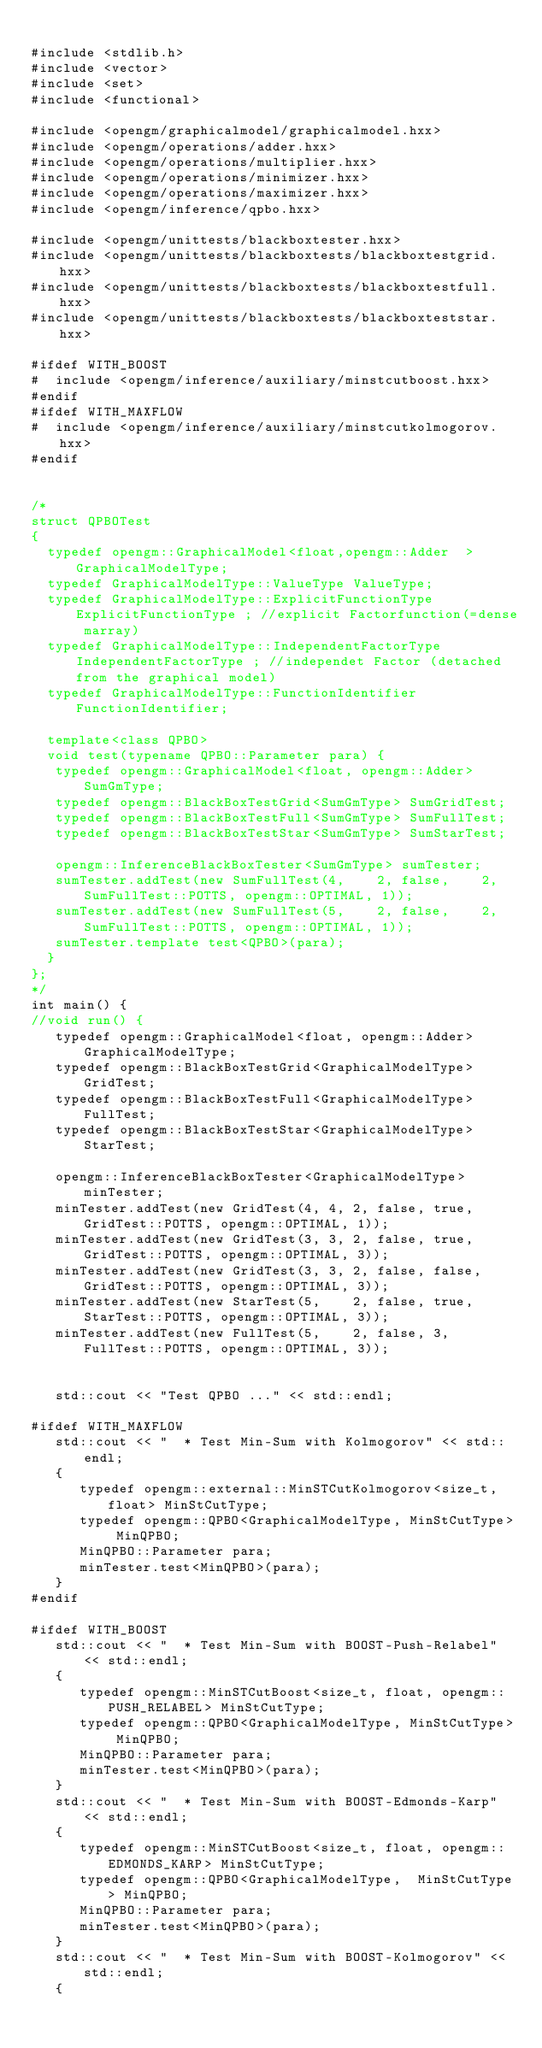Convert code to text. <code><loc_0><loc_0><loc_500><loc_500><_C++_>
#include <stdlib.h>
#include <vector>
#include <set>
#include <functional>

#include <opengm/graphicalmodel/graphicalmodel.hxx>
#include <opengm/operations/adder.hxx>
#include <opengm/operations/multiplier.hxx>
#include <opengm/operations/minimizer.hxx>
#include <opengm/operations/maximizer.hxx>
#include <opengm/inference/qpbo.hxx>

#include <opengm/unittests/blackboxtester.hxx>
#include <opengm/unittests/blackboxtests/blackboxtestgrid.hxx>
#include <opengm/unittests/blackboxtests/blackboxtestfull.hxx>
#include <opengm/unittests/blackboxtests/blackboxteststar.hxx>

#ifdef WITH_BOOST
#  include <opengm/inference/auxiliary/minstcutboost.hxx>
#endif
#ifdef WITH_MAXFLOW
#  include <opengm/inference/auxiliary/minstcutkolmogorov.hxx>
#endif


/*
struct QPBOTest
{
  typedef opengm::GraphicalModel<float,opengm::Adder  > GraphicalModelType;
  typedef GraphicalModelType::ValueType ValueType;
  typedef GraphicalModelType::ExplicitFunctionType ExplicitFunctionType ;	//explicit Factorfunction(=dense marray)
  typedef GraphicalModelType::IndependentFactorType IndependentFactorType ;	//independet Factor (detached from the graphical model)
  typedef GraphicalModelType::FunctionIdentifier FunctionIdentifier;

  template<class QPBO>
  void test(typename QPBO::Parameter para) {
   typedef opengm::GraphicalModel<float, opengm::Adder> SumGmType;
   typedef opengm::BlackBoxTestGrid<SumGmType> SumGridTest;
   typedef opengm::BlackBoxTestFull<SumGmType> SumFullTest;
   typedef opengm::BlackBoxTestStar<SumGmType> SumStarTest;

   opengm::InferenceBlackBoxTester<SumGmType> sumTester;
   sumTester.addTest(new SumFullTest(4,    2, false,    2, SumFullTest::POTTS, opengm::OPTIMAL, 1));
   sumTester.addTest(new SumFullTest(5,    2, false,    2, SumFullTest::POTTS, opengm::OPTIMAL, 1));
   sumTester.template test<QPBO>(para);
  }
};
*/
int main() {
//void run() {
   typedef opengm::GraphicalModel<float, opengm::Adder> GraphicalModelType;
   typedef opengm::BlackBoxTestGrid<GraphicalModelType> GridTest;
   typedef opengm::BlackBoxTestFull<GraphicalModelType> FullTest;
   typedef opengm::BlackBoxTestStar<GraphicalModelType> StarTest;
   
   opengm::InferenceBlackBoxTester<GraphicalModelType> minTester;
   minTester.addTest(new GridTest(4, 4, 2, false, true, GridTest::POTTS, opengm::OPTIMAL, 1));
   minTester.addTest(new GridTest(3, 3, 2, false, true, GridTest::POTTS, opengm::OPTIMAL, 3));
   minTester.addTest(new GridTest(3, 3, 2, false, false,GridTest::POTTS, opengm::OPTIMAL, 3));
   minTester.addTest(new StarTest(5,    2, false, true, StarTest::POTTS, opengm::OPTIMAL, 3));
   minTester.addTest(new FullTest(5,    2, false, 3,    FullTest::POTTS, opengm::OPTIMAL, 3));
   
   
   std::cout << "Test QPBO ..." << std::endl;
   
#ifdef WITH_MAXFLOW
   std::cout << "  * Test Min-Sum with Kolmogorov" << std::endl;
   {
      typedef opengm::external::MinSTCutKolmogorov<size_t, float> MinStCutType;
      typedef opengm::QPBO<GraphicalModelType, MinStCutType> MinQPBO;
      MinQPBO::Parameter para;
      minTester.test<MinQPBO>(para);
   }
#endif
   
#ifdef WITH_BOOST
   std::cout << "  * Test Min-Sum with BOOST-Push-Relabel" << std::endl;
   {
      typedef opengm::MinSTCutBoost<size_t, float, opengm::PUSH_RELABEL> MinStCutType;
      typedef opengm::QPBO<GraphicalModelType, MinStCutType> MinQPBO;
      MinQPBO::Parameter para;
      minTester.test<MinQPBO>(para);
   }
   std::cout << "  * Test Min-Sum with BOOST-Edmonds-Karp" << std::endl;
   {
      typedef opengm::MinSTCutBoost<size_t, float, opengm::EDMONDS_KARP> MinStCutType;
      typedef opengm::QPBO<GraphicalModelType,  MinStCutType> MinQPBO;
      MinQPBO::Parameter para;
      minTester.test<MinQPBO>(para);
   }
   std::cout << "  * Test Min-Sum with BOOST-Kolmogorov" << std::endl;
   {</code> 